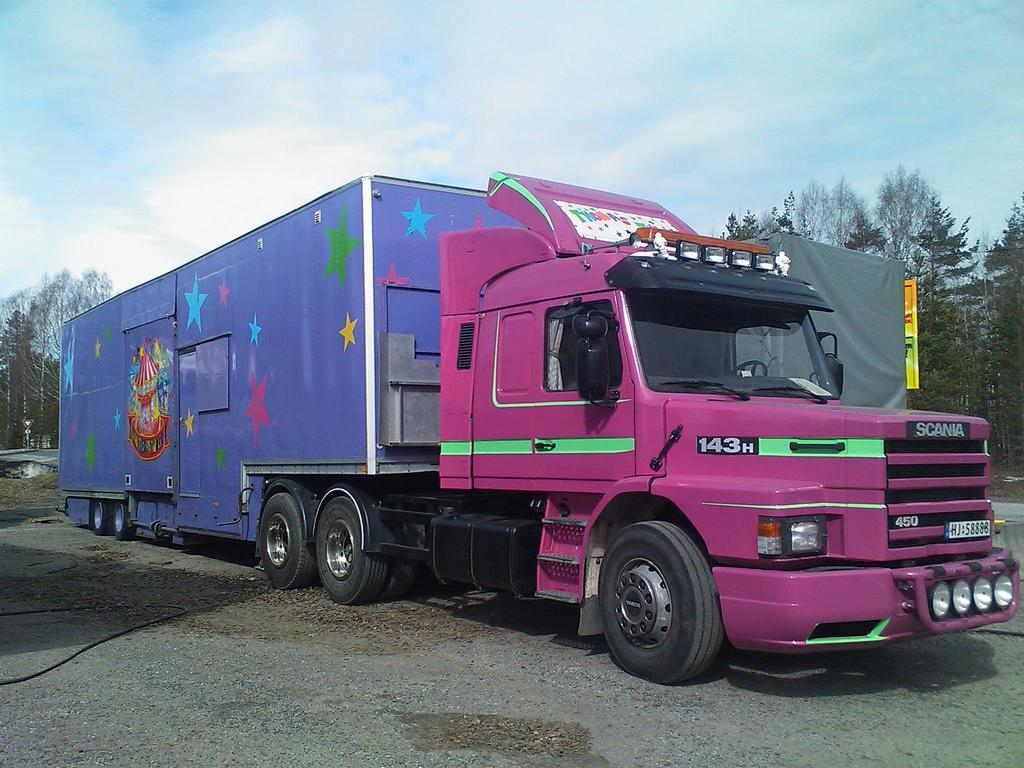What is the main subject of the image? There is a vehicle on the road in the image. What can be seen in the background of the image? There are trees visible in the background of the image. What is visible at the top of the image? The sky is visible at the top of the image. What is the condition of the sky in the image? Clouds are present in the sky. What type of peace can be seen in the image? There is no reference to peace in the image; it features a vehicle on the road, trees in the background, and clouds in the sky. What hobbies are the trees in the image engaged in? Trees are not capable of engaging in hobbies, as they are inanimate objects. 